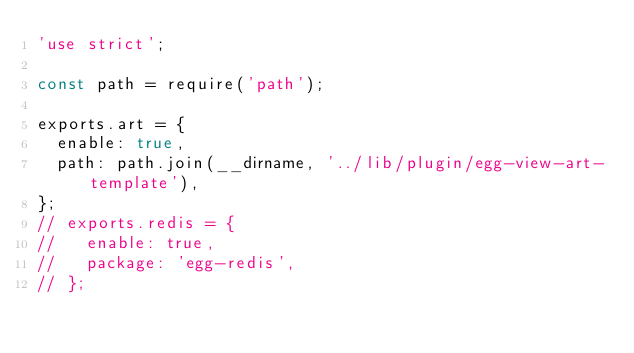<code> <loc_0><loc_0><loc_500><loc_500><_JavaScript_>'use strict';

const path = require('path');

exports.art = {
  enable: true,
  path: path.join(__dirname, '../lib/plugin/egg-view-art-template'),
};
// exports.redis = {
//   enable: true,
//   package: 'egg-redis',
// };
</code> 